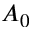Convert formula to latex. <formula><loc_0><loc_0><loc_500><loc_500>A _ { 0 }</formula> 